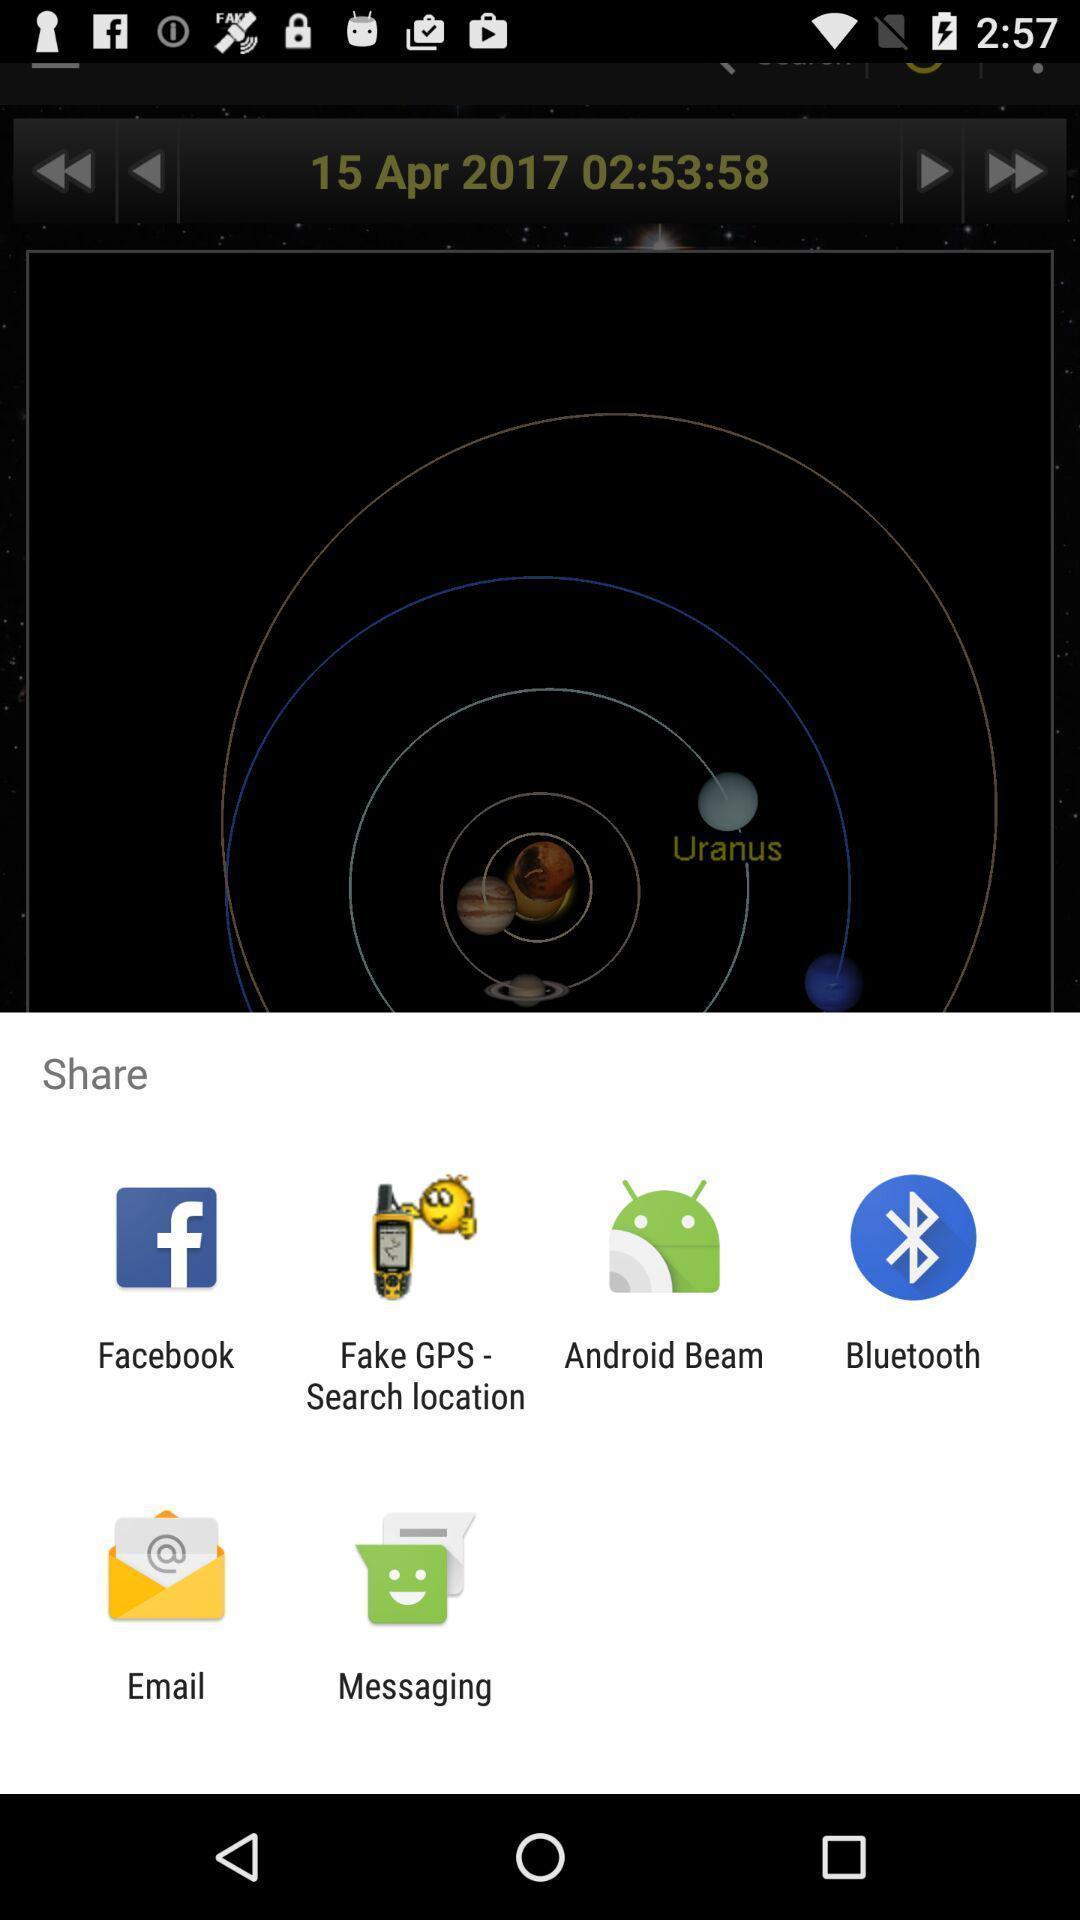Tell me what you see in this picture. Pop-up showing different sharing options. 